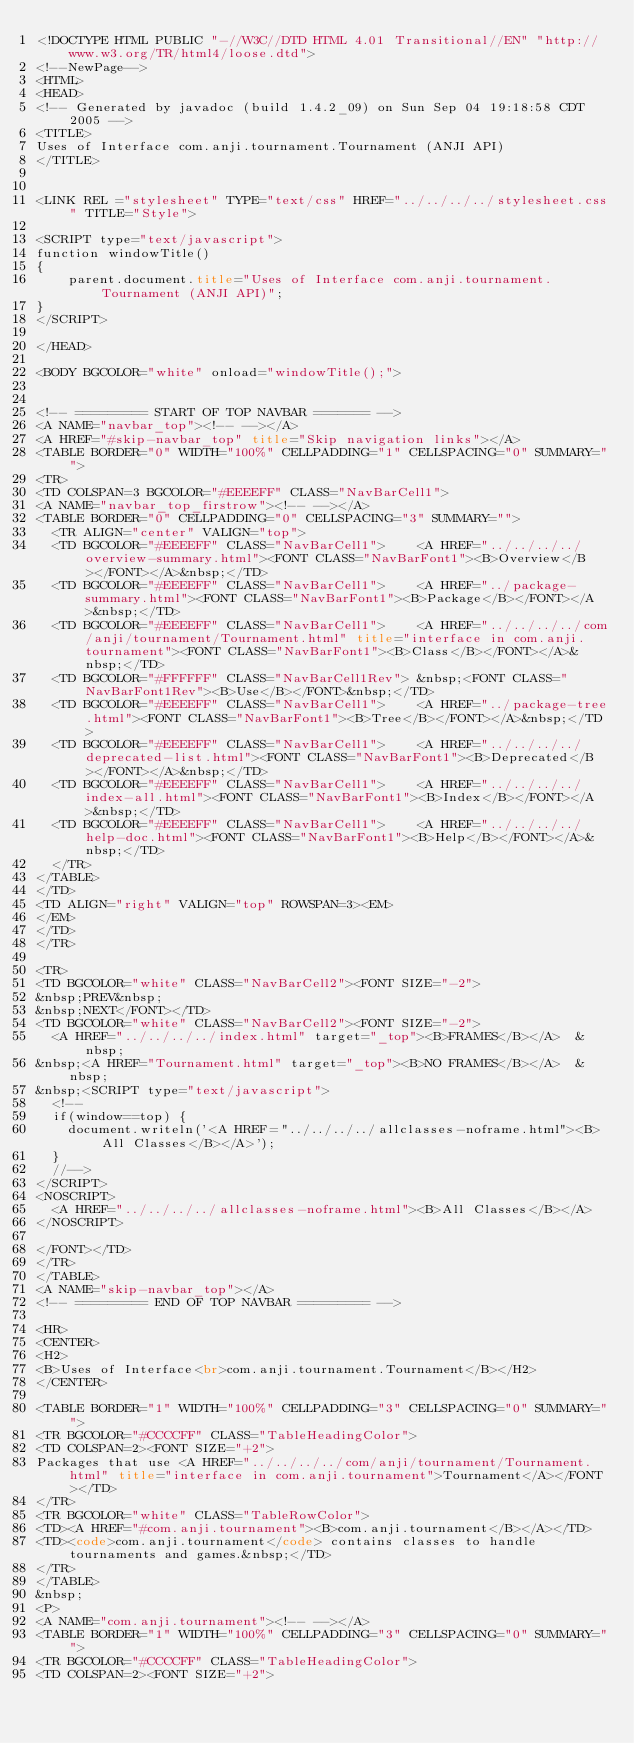Convert code to text. <code><loc_0><loc_0><loc_500><loc_500><_HTML_><!DOCTYPE HTML PUBLIC "-//W3C//DTD HTML 4.01 Transitional//EN" "http://www.w3.org/TR/html4/loose.dtd">
<!--NewPage-->
<HTML>
<HEAD>
<!-- Generated by javadoc (build 1.4.2_09) on Sun Sep 04 19:18:58 CDT 2005 -->
<TITLE>
Uses of Interface com.anji.tournament.Tournament (ANJI API)
</TITLE>


<LINK REL ="stylesheet" TYPE="text/css" HREF="../../../../stylesheet.css" TITLE="Style">

<SCRIPT type="text/javascript">
function windowTitle()
{
    parent.document.title="Uses of Interface com.anji.tournament.Tournament (ANJI API)";
}
</SCRIPT>

</HEAD>

<BODY BGCOLOR="white" onload="windowTitle();">


<!-- ========= START OF TOP NAVBAR ======= -->
<A NAME="navbar_top"><!-- --></A>
<A HREF="#skip-navbar_top" title="Skip navigation links"></A>
<TABLE BORDER="0" WIDTH="100%" CELLPADDING="1" CELLSPACING="0" SUMMARY="">
<TR>
<TD COLSPAN=3 BGCOLOR="#EEEEFF" CLASS="NavBarCell1">
<A NAME="navbar_top_firstrow"><!-- --></A>
<TABLE BORDER="0" CELLPADDING="0" CELLSPACING="3" SUMMARY="">
  <TR ALIGN="center" VALIGN="top">
  <TD BGCOLOR="#EEEEFF" CLASS="NavBarCell1">    <A HREF="../../../../overview-summary.html"><FONT CLASS="NavBarFont1"><B>Overview</B></FONT></A>&nbsp;</TD>
  <TD BGCOLOR="#EEEEFF" CLASS="NavBarCell1">    <A HREF="../package-summary.html"><FONT CLASS="NavBarFont1"><B>Package</B></FONT></A>&nbsp;</TD>
  <TD BGCOLOR="#EEEEFF" CLASS="NavBarCell1">    <A HREF="../../../../com/anji/tournament/Tournament.html" title="interface in com.anji.tournament"><FONT CLASS="NavBarFont1"><B>Class</B></FONT></A>&nbsp;</TD>
  <TD BGCOLOR="#FFFFFF" CLASS="NavBarCell1Rev"> &nbsp;<FONT CLASS="NavBarFont1Rev"><B>Use</B></FONT>&nbsp;</TD>
  <TD BGCOLOR="#EEEEFF" CLASS="NavBarCell1">    <A HREF="../package-tree.html"><FONT CLASS="NavBarFont1"><B>Tree</B></FONT></A>&nbsp;</TD>
  <TD BGCOLOR="#EEEEFF" CLASS="NavBarCell1">    <A HREF="../../../../deprecated-list.html"><FONT CLASS="NavBarFont1"><B>Deprecated</B></FONT></A>&nbsp;</TD>
  <TD BGCOLOR="#EEEEFF" CLASS="NavBarCell1">    <A HREF="../../../../index-all.html"><FONT CLASS="NavBarFont1"><B>Index</B></FONT></A>&nbsp;</TD>
  <TD BGCOLOR="#EEEEFF" CLASS="NavBarCell1">    <A HREF="../../../../help-doc.html"><FONT CLASS="NavBarFont1"><B>Help</B></FONT></A>&nbsp;</TD>
  </TR>
</TABLE>
</TD>
<TD ALIGN="right" VALIGN="top" ROWSPAN=3><EM>
</EM>
</TD>
</TR>

<TR>
<TD BGCOLOR="white" CLASS="NavBarCell2"><FONT SIZE="-2">
&nbsp;PREV&nbsp;
&nbsp;NEXT</FONT></TD>
<TD BGCOLOR="white" CLASS="NavBarCell2"><FONT SIZE="-2">
  <A HREF="../../../../index.html" target="_top"><B>FRAMES</B></A>  &nbsp;
&nbsp;<A HREF="Tournament.html" target="_top"><B>NO FRAMES</B></A>  &nbsp;
&nbsp;<SCRIPT type="text/javascript">
  <!--
  if(window==top) {
    document.writeln('<A HREF="../../../../allclasses-noframe.html"><B>All Classes</B></A>');
  }
  //-->
</SCRIPT>
<NOSCRIPT>
  <A HREF="../../../../allclasses-noframe.html"><B>All Classes</B></A>
</NOSCRIPT>

</FONT></TD>
</TR>
</TABLE>
<A NAME="skip-navbar_top"></A>
<!-- ========= END OF TOP NAVBAR ========= -->

<HR>
<CENTER>
<H2>
<B>Uses of Interface<br>com.anji.tournament.Tournament</B></H2>
</CENTER>

<TABLE BORDER="1" WIDTH="100%" CELLPADDING="3" CELLSPACING="0" SUMMARY="">
<TR BGCOLOR="#CCCCFF" CLASS="TableHeadingColor">
<TD COLSPAN=2><FONT SIZE="+2">
Packages that use <A HREF="../../../../com/anji/tournament/Tournament.html" title="interface in com.anji.tournament">Tournament</A></FONT></TD>
</TR>
<TR BGCOLOR="white" CLASS="TableRowColor">
<TD><A HREF="#com.anji.tournament"><B>com.anji.tournament</B></A></TD>
<TD><code>com.anji.tournament</code> contains classes to handle tournaments and games.&nbsp;</TD>
</TR>
</TABLE>
&nbsp;
<P>
<A NAME="com.anji.tournament"><!-- --></A>
<TABLE BORDER="1" WIDTH="100%" CELLPADDING="3" CELLSPACING="0" SUMMARY="">
<TR BGCOLOR="#CCCCFF" CLASS="TableHeadingColor">
<TD COLSPAN=2><FONT SIZE="+2"></code> 